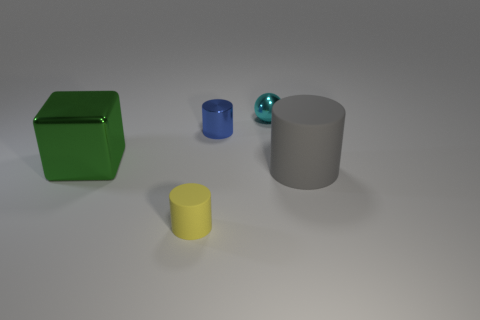Subtract all small yellow matte cylinders. How many cylinders are left? 2 Subtract all gray cylinders. How many cylinders are left? 2 Add 1 tiny shiny spheres. How many objects exist? 6 Subtract all cylinders. How many objects are left? 2 Subtract 2 cylinders. How many cylinders are left? 1 Add 1 shiny cylinders. How many shiny cylinders exist? 2 Subtract 0 gray spheres. How many objects are left? 5 Subtract all purple blocks. Subtract all green cylinders. How many blocks are left? 1 Subtract all yellow cubes. How many yellow cylinders are left? 1 Subtract all yellow things. Subtract all tiny cyan metallic balls. How many objects are left? 3 